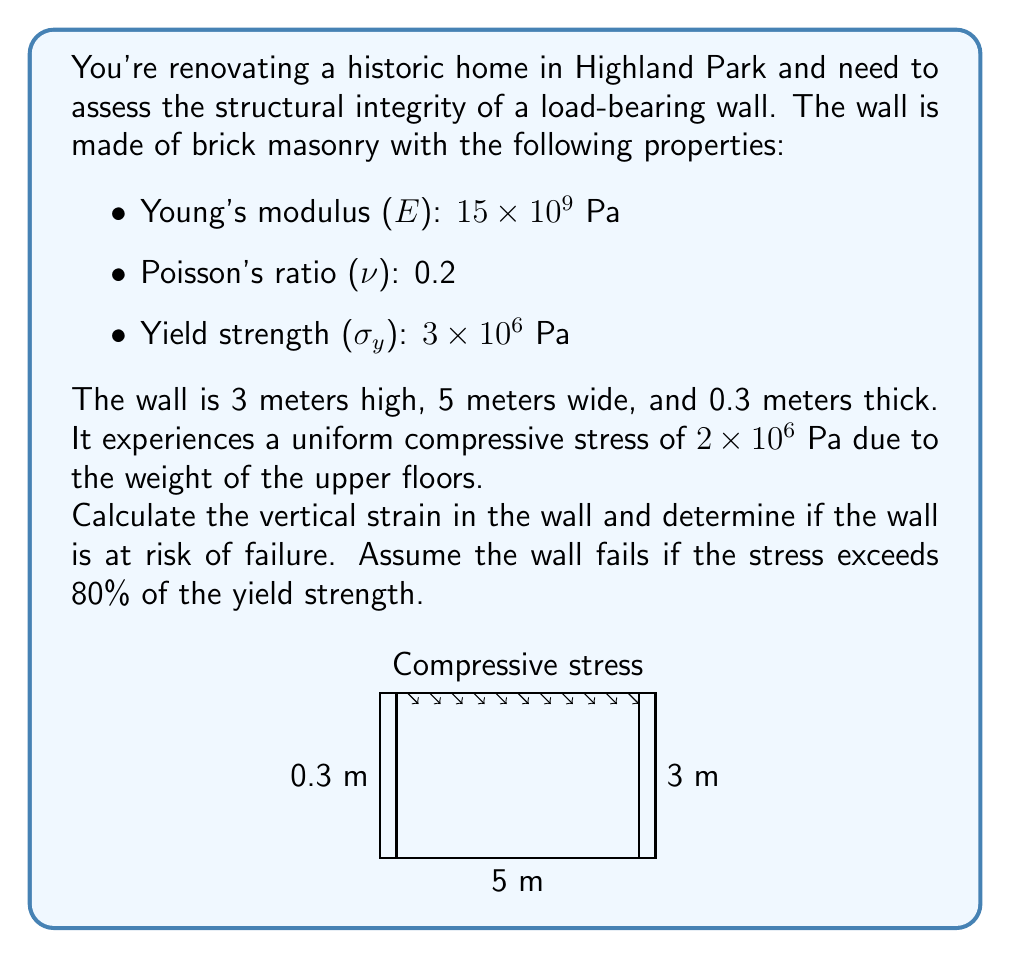Give your solution to this math problem. Let's approach this problem step-by-step:

1) First, we need to calculate the vertical strain (ε) using Hooke's law:

   $$\varepsilon = \frac{\sigma}{E}$$

   where σ is the stress and E is Young's modulus.

2) Plugging in the values:

   $$\varepsilon = \frac{2 \times 10^6 \text{ Pa}}{15 \times 10^9 \text{ Pa}} = 1.33 \times 10^{-4}$$

3) To determine if the wall is at risk of failure, we need to compare the applied stress to 80% of the yield strength:

   80% of yield strength = $0.8 \times 3 \times 10^6 \text{ Pa} = 2.4 \times 10^6 \text{ Pa}$

4) The applied stress ($2 \times 10^6 \text{ Pa}$) is less than 80% of the yield strength ($2.4 \times 10^6 \text{ Pa}$).

5) We can also calculate the safety factor:

   $$\text{Safety Factor} = \frac{\text{Yield Strength}}{\text{Applied Stress}} = \frac{3 \times 10^6}{2 \times 10^6} = 1.5$$

   A safety factor greater than 1 indicates that the structure is safe under the given load.
Answer: Vertical strain: $1.33 \times 10^{-4}$; Wall is not at risk of failure. 